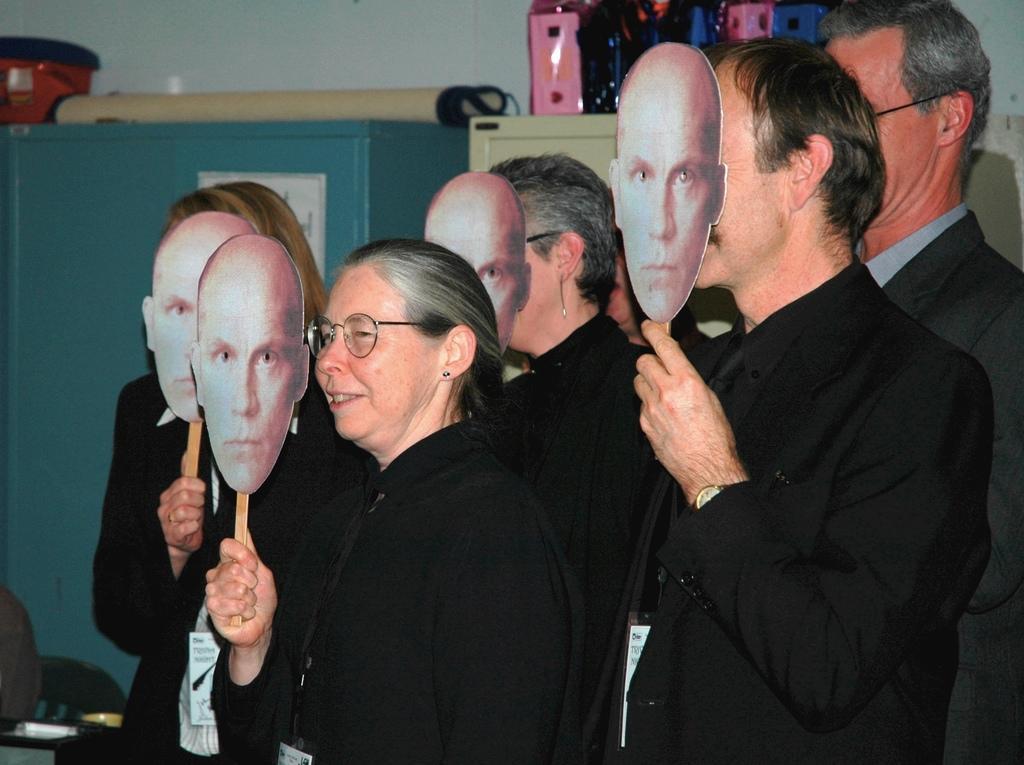In one or two sentences, can you explain what this image depicts? In this image there are people standing, holding masks in their hands, in the background there are cabinets, on top there are objects. 